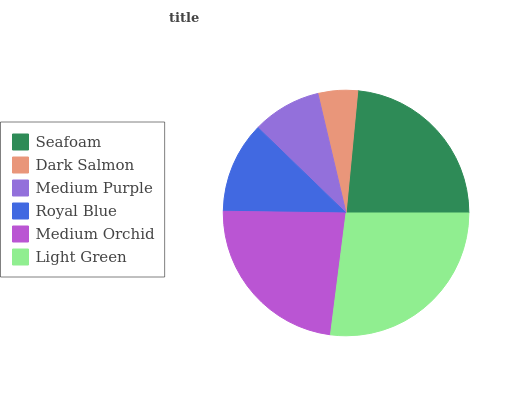Is Dark Salmon the minimum?
Answer yes or no. Yes. Is Light Green the maximum?
Answer yes or no. Yes. Is Medium Purple the minimum?
Answer yes or no. No. Is Medium Purple the maximum?
Answer yes or no. No. Is Medium Purple greater than Dark Salmon?
Answer yes or no. Yes. Is Dark Salmon less than Medium Purple?
Answer yes or no. Yes. Is Dark Salmon greater than Medium Purple?
Answer yes or no. No. Is Medium Purple less than Dark Salmon?
Answer yes or no. No. Is Medium Orchid the high median?
Answer yes or no. Yes. Is Royal Blue the low median?
Answer yes or no. Yes. Is Medium Purple the high median?
Answer yes or no. No. Is Medium Orchid the low median?
Answer yes or no. No. 